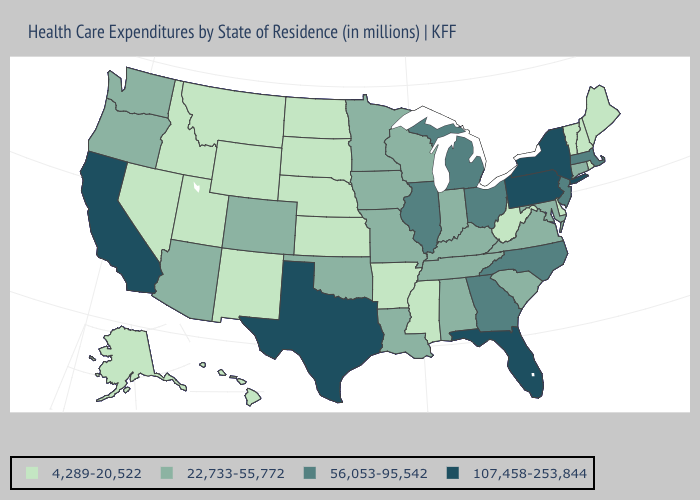What is the value of Idaho?
Be succinct. 4,289-20,522. Name the states that have a value in the range 107,458-253,844?
Write a very short answer. California, Florida, New York, Pennsylvania, Texas. Name the states that have a value in the range 22,733-55,772?
Concise answer only. Alabama, Arizona, Colorado, Connecticut, Indiana, Iowa, Kentucky, Louisiana, Maryland, Minnesota, Missouri, Oklahoma, Oregon, South Carolina, Tennessee, Virginia, Washington, Wisconsin. Name the states that have a value in the range 56,053-95,542?
Keep it brief. Georgia, Illinois, Massachusetts, Michigan, New Jersey, North Carolina, Ohio. Which states have the highest value in the USA?
Keep it brief. California, Florida, New York, Pennsylvania, Texas. Name the states that have a value in the range 107,458-253,844?
Concise answer only. California, Florida, New York, Pennsylvania, Texas. What is the highest value in the USA?
Keep it brief. 107,458-253,844. Among the states that border Mississippi , does Tennessee have the lowest value?
Be succinct. No. What is the lowest value in states that border Louisiana?
Be succinct. 4,289-20,522. What is the highest value in states that border Maryland?
Write a very short answer. 107,458-253,844. What is the value of Louisiana?
Quick response, please. 22,733-55,772. Does Illinois have a lower value than Montana?
Quick response, please. No. Name the states that have a value in the range 4,289-20,522?
Keep it brief. Alaska, Arkansas, Delaware, Hawaii, Idaho, Kansas, Maine, Mississippi, Montana, Nebraska, Nevada, New Hampshire, New Mexico, North Dakota, Rhode Island, South Dakota, Utah, Vermont, West Virginia, Wyoming. Among the states that border California , does Oregon have the highest value?
Give a very brief answer. Yes. What is the lowest value in the USA?
Answer briefly. 4,289-20,522. 